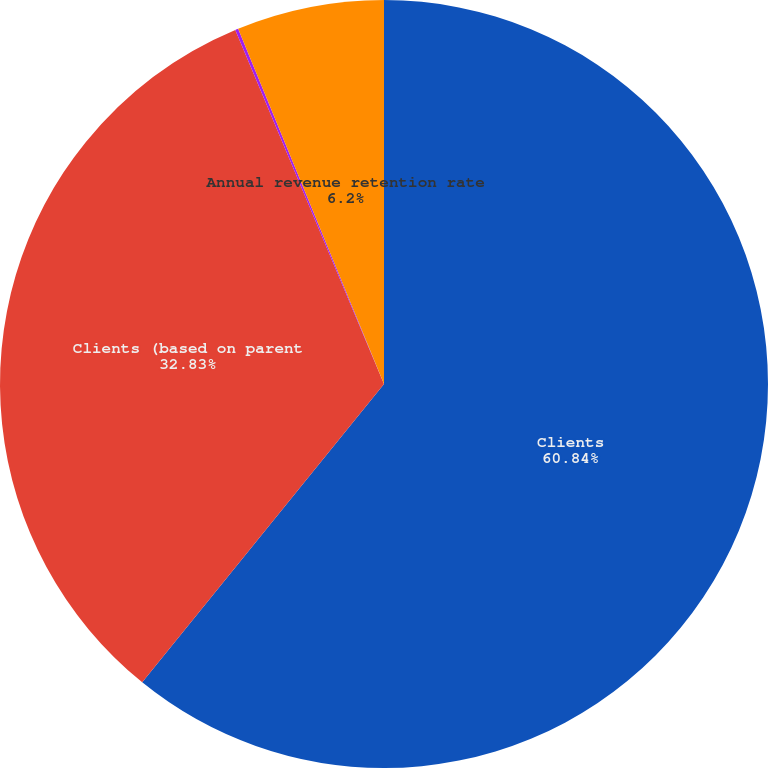Convert chart. <chart><loc_0><loc_0><loc_500><loc_500><pie_chart><fcel>Clients<fcel>Clients (based on parent<fcel>Sales teams<fcel>Annual revenue retention rate<nl><fcel>60.84%<fcel>32.83%<fcel>0.13%<fcel>6.2%<nl></chart> 